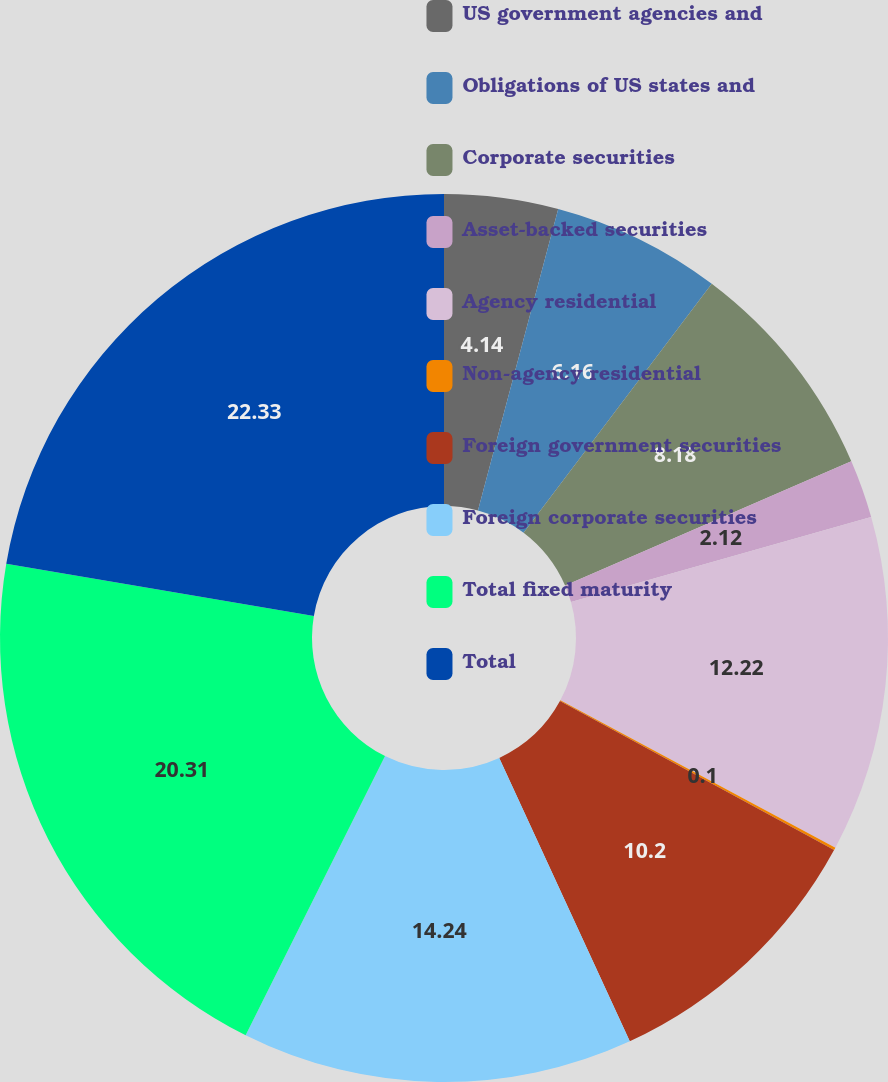Convert chart. <chart><loc_0><loc_0><loc_500><loc_500><pie_chart><fcel>US government agencies and<fcel>Obligations of US states and<fcel>Corporate securities<fcel>Asset-backed securities<fcel>Agency residential<fcel>Non-agency residential<fcel>Foreign government securities<fcel>Foreign corporate securities<fcel>Total fixed maturity<fcel>Total<nl><fcel>4.14%<fcel>6.16%<fcel>8.18%<fcel>2.12%<fcel>12.22%<fcel>0.1%<fcel>10.2%<fcel>14.24%<fcel>20.3%<fcel>22.32%<nl></chart> 